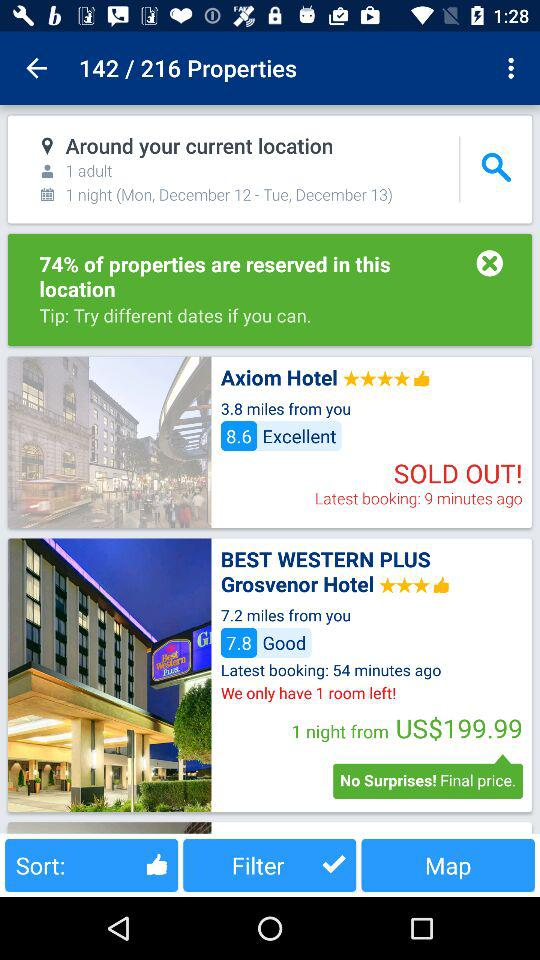How far is the "BEST WESTERN PLUS Grosvenor Hotel" from the given location? The "BEST WESTERN PLUS Grosvenor Hotel" is 7.2 miles away. 